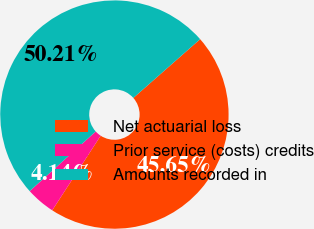Convert chart. <chart><loc_0><loc_0><loc_500><loc_500><pie_chart><fcel>Net actuarial loss<fcel>Prior service (costs) credits<fcel>Amounts recorded in<nl><fcel>45.65%<fcel>4.14%<fcel>50.21%<nl></chart> 